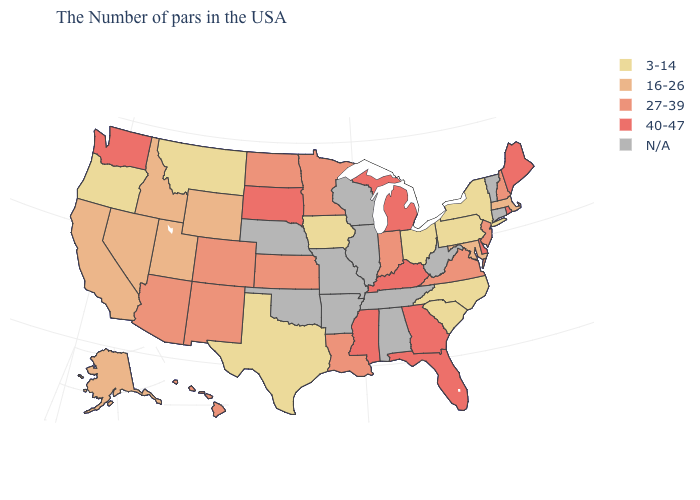Which states hav the highest value in the West?
Keep it brief. Washington. Name the states that have a value in the range 3-14?
Give a very brief answer. New York, Pennsylvania, North Carolina, South Carolina, Ohio, Iowa, Texas, Montana, Oregon. What is the lowest value in the USA?
Quick response, please. 3-14. Does Ohio have the highest value in the MidWest?
Concise answer only. No. Does the map have missing data?
Short answer required. Yes. Does Rhode Island have the highest value in the Northeast?
Give a very brief answer. Yes. Name the states that have a value in the range 40-47?
Answer briefly. Maine, Rhode Island, Delaware, Florida, Georgia, Michigan, Kentucky, Mississippi, South Dakota, Washington. Which states hav the highest value in the MidWest?
Concise answer only. Michigan, South Dakota. Which states have the lowest value in the Northeast?
Write a very short answer. New York, Pennsylvania. Among the states that border Minnesota , does North Dakota have the highest value?
Keep it brief. No. Name the states that have a value in the range 3-14?
Be succinct. New York, Pennsylvania, North Carolina, South Carolina, Ohio, Iowa, Texas, Montana, Oregon. Does Delaware have the highest value in the USA?
Write a very short answer. Yes. Does South Carolina have the lowest value in the USA?
Short answer required. Yes. Name the states that have a value in the range N/A?
Short answer required. Vermont, Connecticut, West Virginia, Alabama, Tennessee, Wisconsin, Illinois, Missouri, Arkansas, Nebraska, Oklahoma. 